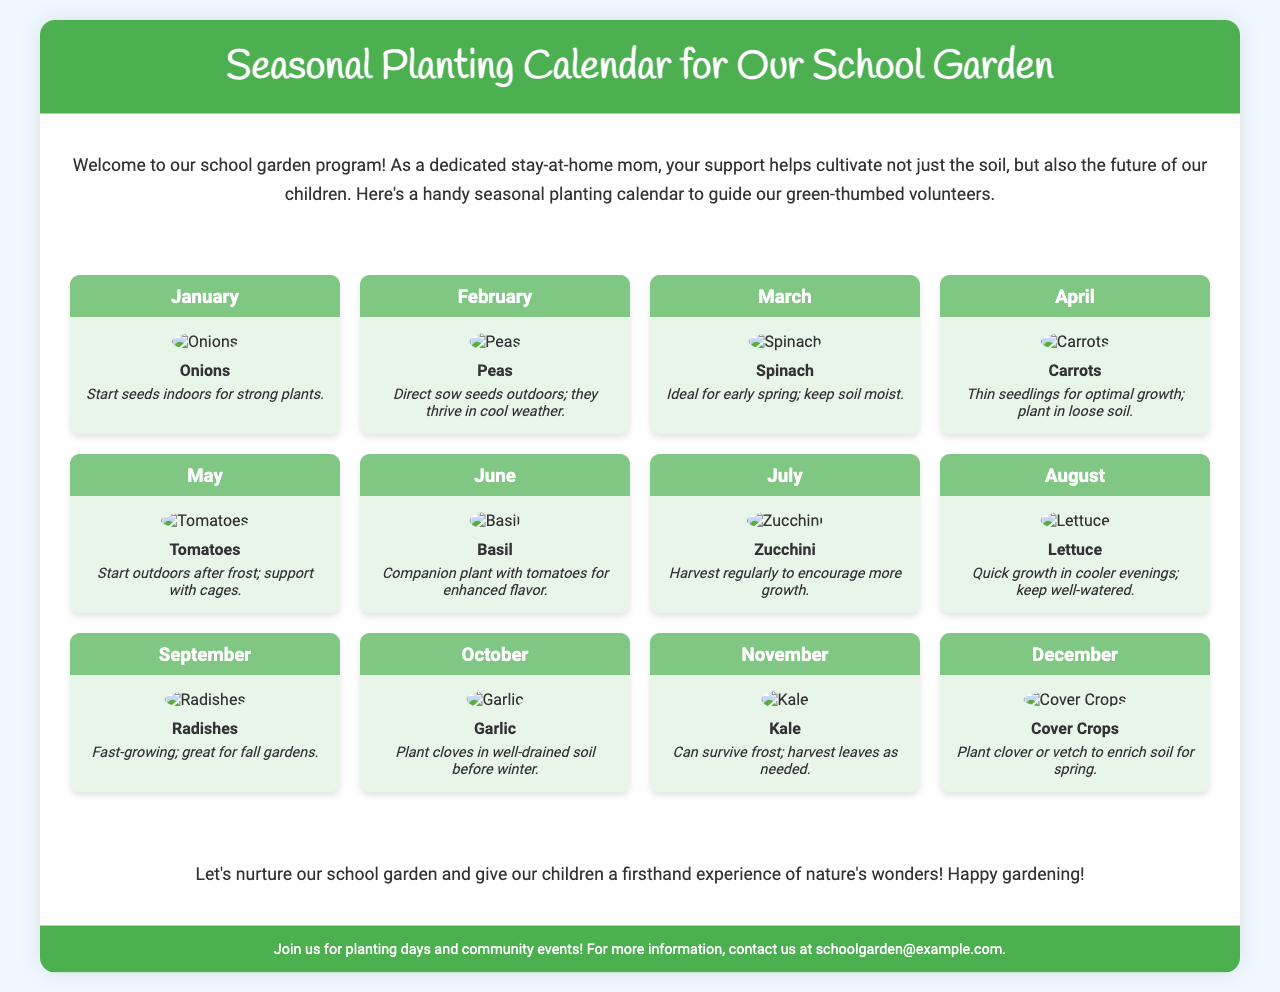What is the title of the document? The title is found in the header section of the document, stated clearly in large font.
Answer: Seasonal Planting Calendar for Our School Garden Which crop is suggested for planting in February? Each month contains information about specific crops, and February's crop is listed in the corresponding month box.
Answer: Peas What tip is provided for growing onions? Each crop has a specific care tip listed beneath its name in the crop info section.
Answer: Start seeds indoors for strong plants How many months are covered in this planting calendar? The document provides a calendar for each month of the year, so the count of months is directly linked to the number of month sections present.
Answer: Twelve What vegetable is recommended for planting in June? The June section displays the crop name and care tips specifically related to that month.
Answer: Basil What is a suggested practice for harvesting zucchini? Each crop includes a tip, found in the tip section of the corresponding month, which advises on harvest practices.
Answer: Harvest regularly to encourage more growth What type of crops should be planted in December? The December section indicates what to plant during that month, highlighting specific crop types appropriate for that time.
Answer: Cover Crops Which crop can survive frost? The tip for November notes a specific crop that can withstand colder temperatures.
Answer: Kale 